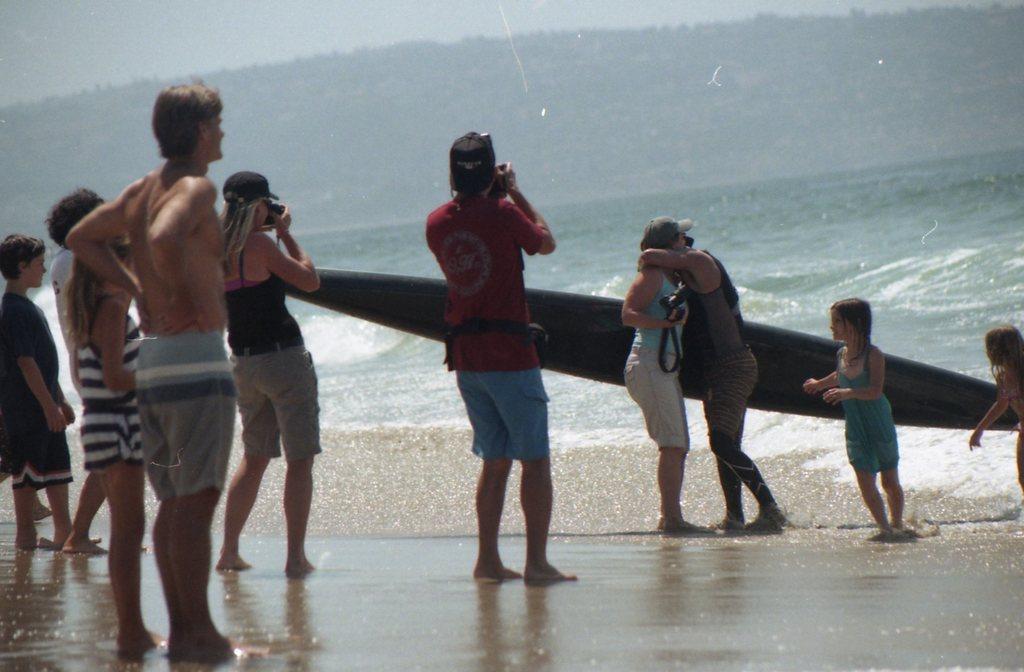Could you give a brief overview of what you see in this image? Background is very blurry. This is a sea. In Front of a sea we can able to see few persons standing and few are taking the snaps. This is a surfboard. 